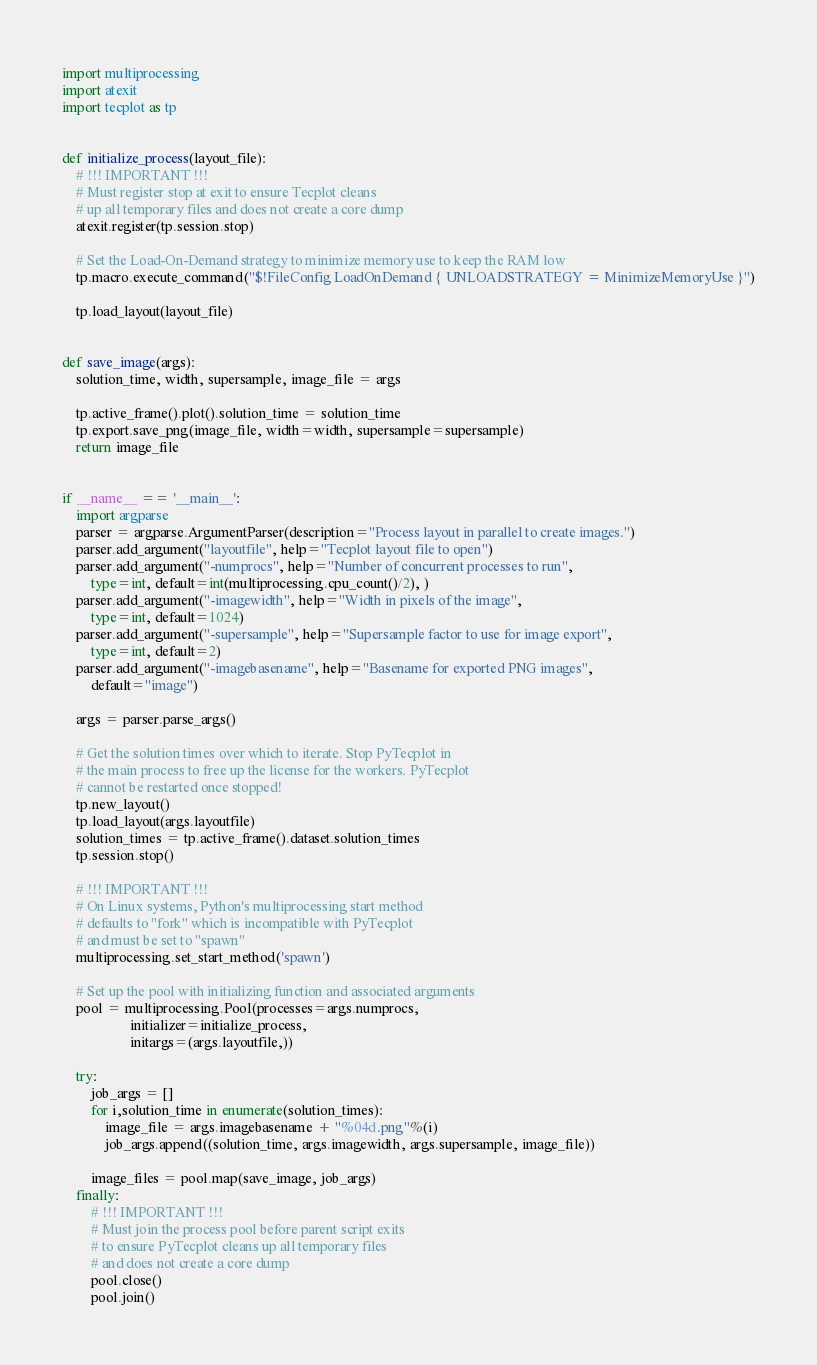Convert code to text. <code><loc_0><loc_0><loc_500><loc_500><_Python_>import multiprocessing
import atexit
import tecplot as tp


def initialize_process(layout_file):
    # !!! IMPORTANT !!!
    # Must register stop at exit to ensure Tecplot cleans
    # up all temporary files and does not create a core dump
    atexit.register(tp.session.stop)
    
    # Set the Load-On-Demand strategy to minimize memory use to keep the RAM low
    tp.macro.execute_command("$!FileConfig LoadOnDemand { UNLOADSTRATEGY = MinimizeMemoryUse }")
    
    tp.load_layout(layout_file)
    
    
def save_image(args):
    solution_time, width, supersample, image_file = args
    
    tp.active_frame().plot().solution_time = solution_time
    tp.export.save_png(image_file, width=width, supersample=supersample)
    return image_file

    
if __name__ == '__main__':
    import argparse
    parser = argparse.ArgumentParser(description="Process layout in parallel to create images.")
    parser.add_argument("layoutfile", help="Tecplot layout file to open")
    parser.add_argument("-numprocs", help="Number of concurrent processes to run", 
        type=int, default=int(multiprocessing.cpu_count()/2), )
    parser.add_argument("-imagewidth", help="Width in pixels of the image",
        type=int, default=1024)
    parser.add_argument("-supersample", help="Supersample factor to use for image export",
        type=int, default=2)
    parser.add_argument("-imagebasename", help="Basename for exported PNG images",
        default="image")
    
    args = parser.parse_args()
    
    # Get the solution times over which to iterate. Stop PyTecplot in
    # the main process to free up the license for the workers. PyTecplot
    # cannot be restarted once stopped!
    tp.new_layout()
    tp.load_layout(args.layoutfile)
    solution_times = tp.active_frame().dataset.solution_times
    tp.session.stop()
    
    # !!! IMPORTANT !!!
    # On Linux systems, Python's multiprocessing start method
    # defaults to "fork" which is incompatible with PyTecplot
    # and must be set to "spawn"
    multiprocessing.set_start_method('spawn')
    
    # Set up the pool with initializing function and associated arguments
    pool = multiprocessing.Pool(processes=args.numprocs,
                   initializer=initialize_process,
                   initargs=(args.layoutfile,))
                   
    try:
        job_args = []
        for i,solution_time in enumerate(solution_times):
            image_file = args.imagebasename + "%04d.png"%(i)
            job_args.append((solution_time, args.imagewidth, args.supersample, image_file))
        
        image_files = pool.map(save_image, job_args)
    finally:
        # !!! IMPORTANT !!!
        # Must join the process pool before parent script exits
        # to ensure PyTecplot cleans up all temporary files
        # and does not create a core dump
        pool.close()
        pool.join()
</code> 